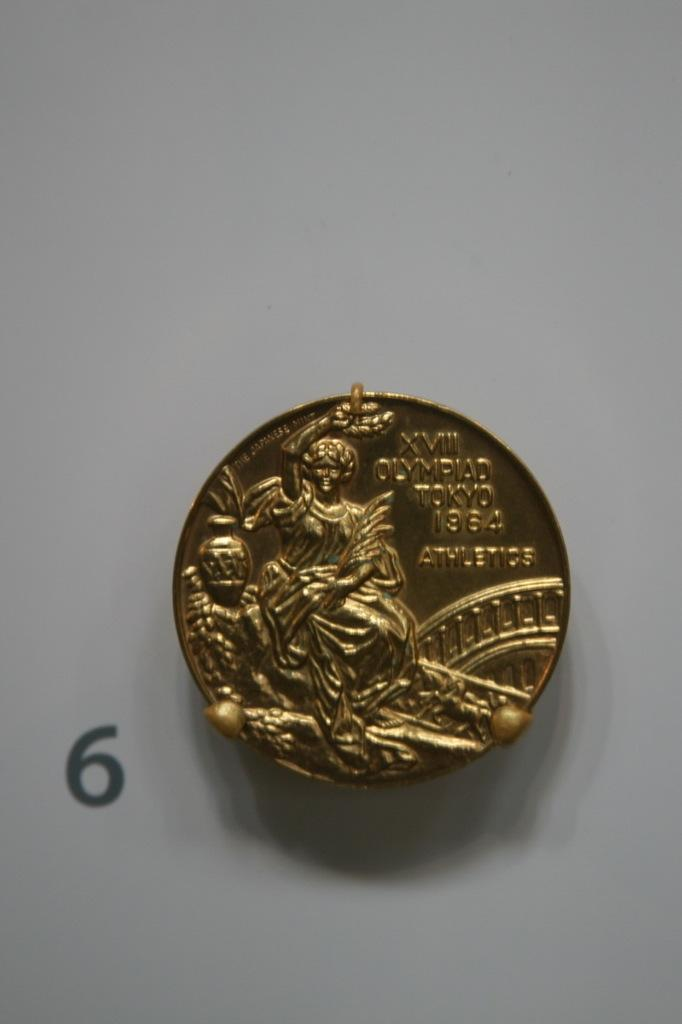<image>
Render a clear and concise summary of the photo. gold coin from xvii tokyo from 1964 is on the tale 